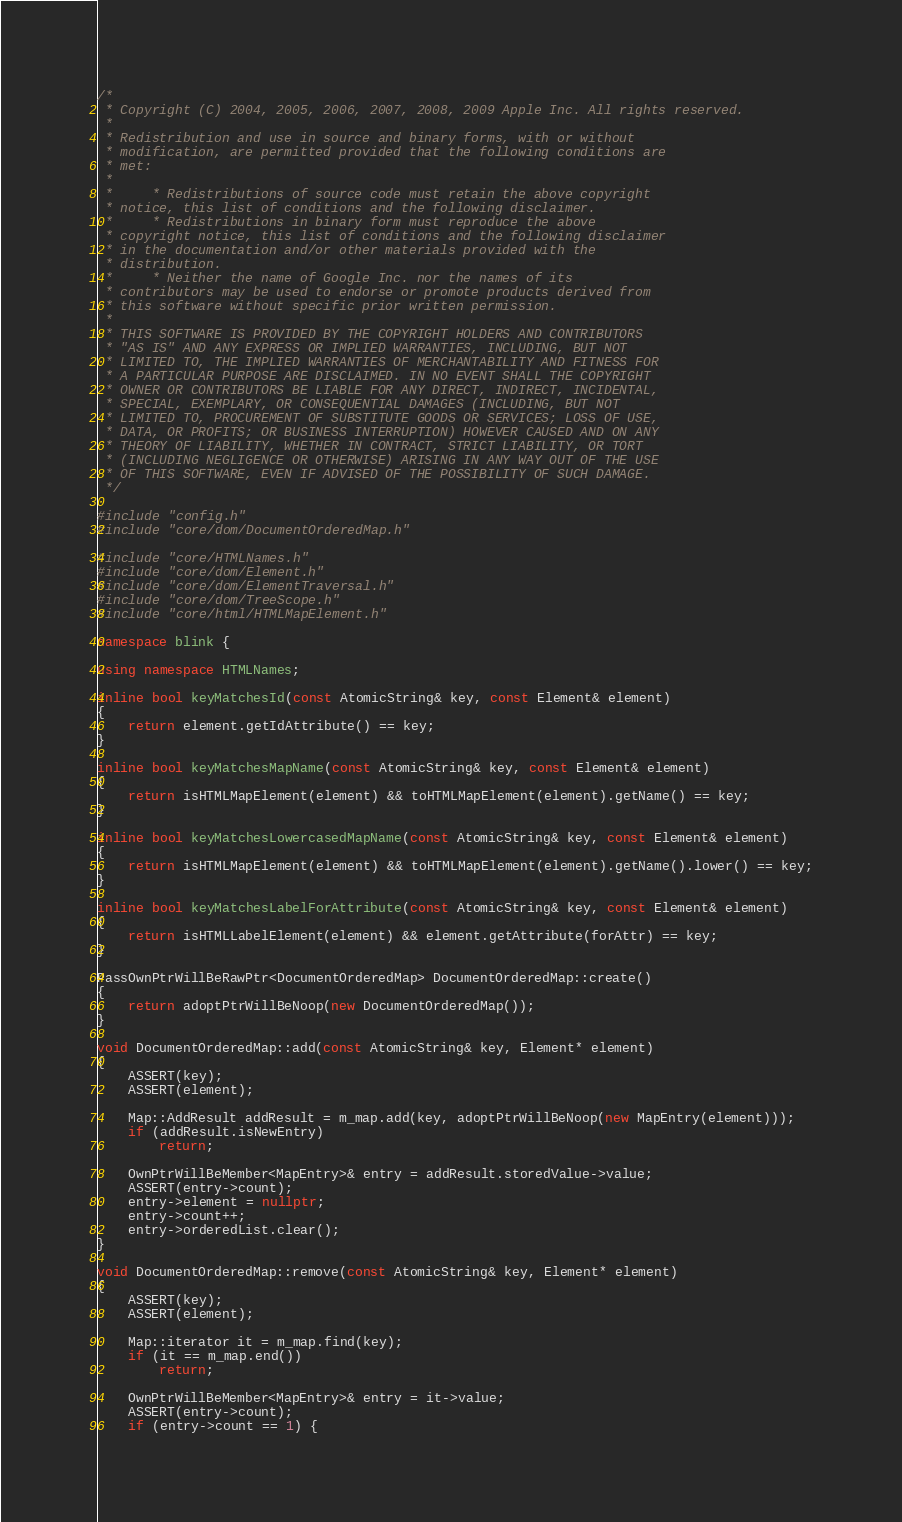<code> <loc_0><loc_0><loc_500><loc_500><_C++_>/*
 * Copyright (C) 2004, 2005, 2006, 2007, 2008, 2009 Apple Inc. All rights reserved.
 *
 * Redistribution and use in source and binary forms, with or without
 * modification, are permitted provided that the following conditions are
 * met:
 *
 *     * Redistributions of source code must retain the above copyright
 * notice, this list of conditions and the following disclaimer.
 *     * Redistributions in binary form must reproduce the above
 * copyright notice, this list of conditions and the following disclaimer
 * in the documentation and/or other materials provided with the
 * distribution.
 *     * Neither the name of Google Inc. nor the names of its
 * contributors may be used to endorse or promote products derived from
 * this software without specific prior written permission.
 *
 * THIS SOFTWARE IS PROVIDED BY THE COPYRIGHT HOLDERS AND CONTRIBUTORS
 * "AS IS" AND ANY EXPRESS OR IMPLIED WARRANTIES, INCLUDING, BUT NOT
 * LIMITED TO, THE IMPLIED WARRANTIES OF MERCHANTABILITY AND FITNESS FOR
 * A PARTICULAR PURPOSE ARE DISCLAIMED. IN NO EVENT SHALL THE COPYRIGHT
 * OWNER OR CONTRIBUTORS BE LIABLE FOR ANY DIRECT, INDIRECT, INCIDENTAL,
 * SPECIAL, EXEMPLARY, OR CONSEQUENTIAL DAMAGES (INCLUDING, BUT NOT
 * LIMITED TO, PROCUREMENT OF SUBSTITUTE GOODS OR SERVICES; LOSS OF USE,
 * DATA, OR PROFITS; OR BUSINESS INTERRUPTION) HOWEVER CAUSED AND ON ANY
 * THEORY OF LIABILITY, WHETHER IN CONTRACT, STRICT LIABILITY, OR TORT
 * (INCLUDING NEGLIGENCE OR OTHERWISE) ARISING IN ANY WAY OUT OF THE USE
 * OF THIS SOFTWARE, EVEN IF ADVISED OF THE POSSIBILITY OF SUCH DAMAGE.
 */

#include "config.h"
#include "core/dom/DocumentOrderedMap.h"

#include "core/HTMLNames.h"
#include "core/dom/Element.h"
#include "core/dom/ElementTraversal.h"
#include "core/dom/TreeScope.h"
#include "core/html/HTMLMapElement.h"

namespace blink {

using namespace HTMLNames;

inline bool keyMatchesId(const AtomicString& key, const Element& element)
{
    return element.getIdAttribute() == key;
}

inline bool keyMatchesMapName(const AtomicString& key, const Element& element)
{
    return isHTMLMapElement(element) && toHTMLMapElement(element).getName() == key;
}

inline bool keyMatchesLowercasedMapName(const AtomicString& key, const Element& element)
{
    return isHTMLMapElement(element) && toHTMLMapElement(element).getName().lower() == key;
}

inline bool keyMatchesLabelForAttribute(const AtomicString& key, const Element& element)
{
    return isHTMLLabelElement(element) && element.getAttribute(forAttr) == key;
}

PassOwnPtrWillBeRawPtr<DocumentOrderedMap> DocumentOrderedMap::create()
{
    return adoptPtrWillBeNoop(new DocumentOrderedMap());
}

void DocumentOrderedMap::add(const AtomicString& key, Element* element)
{
    ASSERT(key);
    ASSERT(element);

    Map::AddResult addResult = m_map.add(key, adoptPtrWillBeNoop(new MapEntry(element)));
    if (addResult.isNewEntry)
        return;

    OwnPtrWillBeMember<MapEntry>& entry = addResult.storedValue->value;
    ASSERT(entry->count);
    entry->element = nullptr;
    entry->count++;
    entry->orderedList.clear();
}

void DocumentOrderedMap::remove(const AtomicString& key, Element* element)
{
    ASSERT(key);
    ASSERT(element);

    Map::iterator it = m_map.find(key);
    if (it == m_map.end())
        return;

    OwnPtrWillBeMember<MapEntry>& entry = it->value;
    ASSERT(entry->count);
    if (entry->count == 1) {</code> 